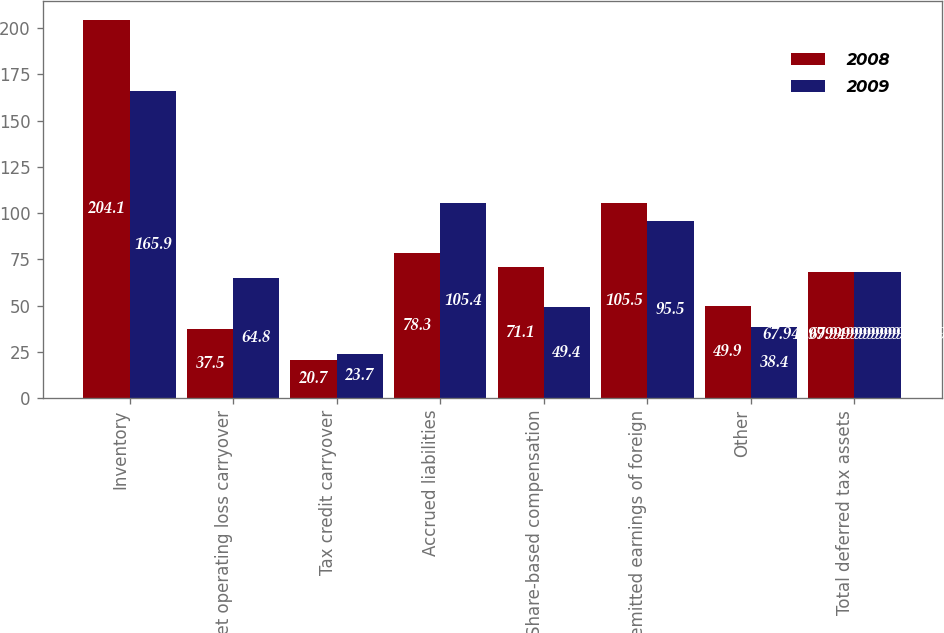Convert chart to OTSL. <chart><loc_0><loc_0><loc_500><loc_500><stacked_bar_chart><ecel><fcel>Inventory<fcel>Net operating loss carryover<fcel>Tax credit carryover<fcel>Accrued liabilities<fcel>Share-based compensation<fcel>Unremitted earnings of foreign<fcel>Other<fcel>Total deferred tax assets<nl><fcel>2008<fcel>204.1<fcel>37.5<fcel>20.7<fcel>78.3<fcel>71.1<fcel>105.5<fcel>49.9<fcel>67.95<nl><fcel>2009<fcel>165.9<fcel>64.8<fcel>23.7<fcel>105.4<fcel>49.4<fcel>95.5<fcel>38.4<fcel>67.95<nl></chart> 